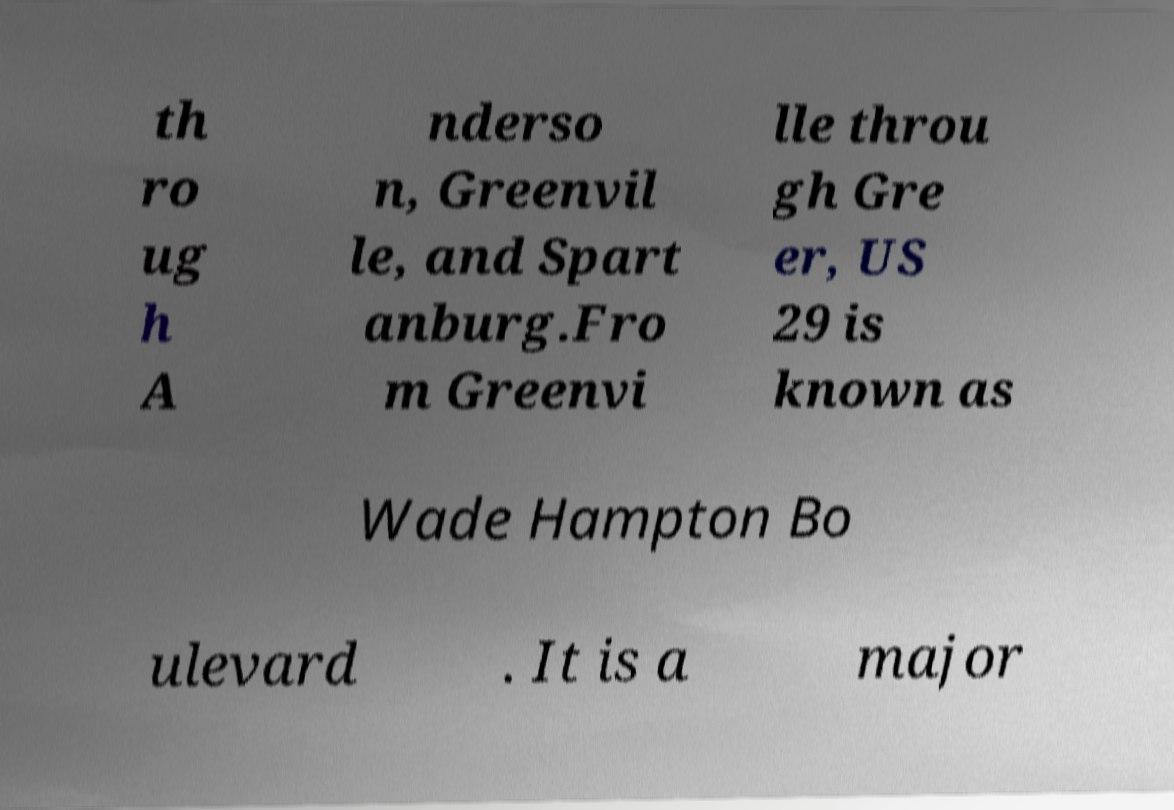For documentation purposes, I need the text within this image transcribed. Could you provide that? th ro ug h A nderso n, Greenvil le, and Spart anburg.Fro m Greenvi lle throu gh Gre er, US 29 is known as Wade Hampton Bo ulevard . It is a major 